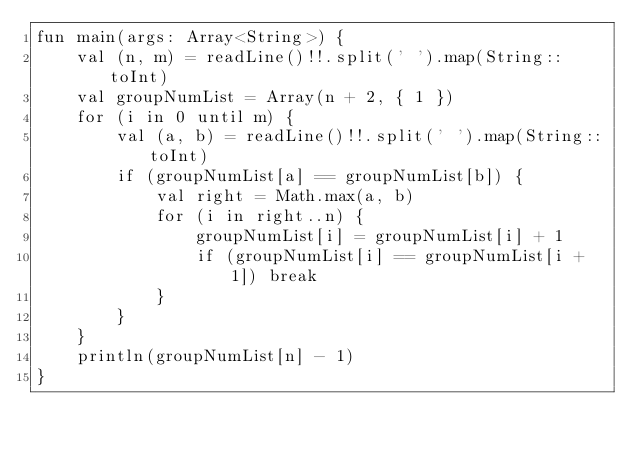Convert code to text. <code><loc_0><loc_0><loc_500><loc_500><_Kotlin_>fun main(args: Array<String>) {
    val (n, m) = readLine()!!.split(' ').map(String::toInt)
    val groupNumList = Array(n + 2, { 1 })
    for (i in 0 until m) {
        val (a, b) = readLine()!!.split(' ').map(String::toInt)
        if (groupNumList[a] == groupNumList[b]) {
            val right = Math.max(a, b)
            for (i in right..n) {
                groupNumList[i] = groupNumList[i] + 1
                if (groupNumList[i] == groupNumList[i + 1]) break
            }
        }
    }
    println(groupNumList[n] - 1)
}</code> 